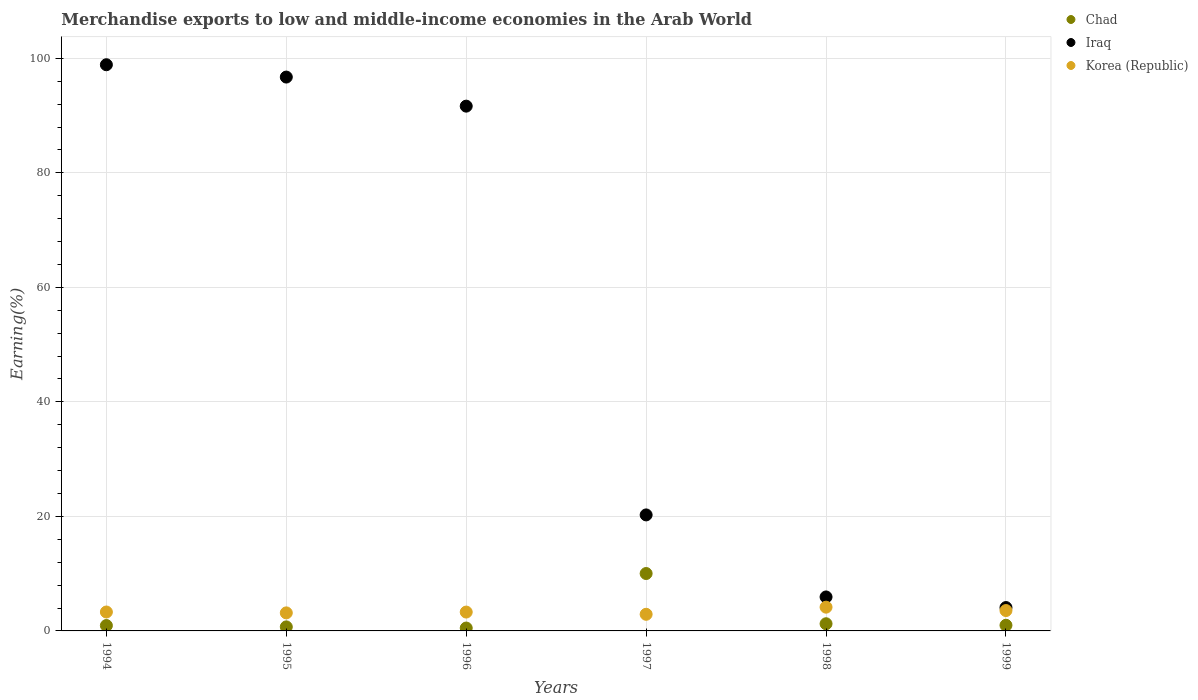What is the percentage of amount earned from merchandise exports in Chad in 1999?
Give a very brief answer. 0.99. Across all years, what is the maximum percentage of amount earned from merchandise exports in Chad?
Provide a succinct answer. 10.02. Across all years, what is the minimum percentage of amount earned from merchandise exports in Korea (Republic)?
Offer a terse response. 2.9. In which year was the percentage of amount earned from merchandise exports in Iraq minimum?
Your response must be concise. 1999. What is the total percentage of amount earned from merchandise exports in Korea (Republic) in the graph?
Offer a very short reply. 20.36. What is the difference between the percentage of amount earned from merchandise exports in Chad in 1995 and that in 1999?
Make the answer very short. -0.28. What is the difference between the percentage of amount earned from merchandise exports in Chad in 1998 and the percentage of amount earned from merchandise exports in Iraq in 1995?
Give a very brief answer. -95.47. What is the average percentage of amount earned from merchandise exports in Korea (Republic) per year?
Your response must be concise. 3.39. In the year 1994, what is the difference between the percentage of amount earned from merchandise exports in Korea (Republic) and percentage of amount earned from merchandise exports in Chad?
Keep it short and to the point. 2.37. What is the ratio of the percentage of amount earned from merchandise exports in Korea (Republic) in 1996 to that in 1997?
Your response must be concise. 1.13. What is the difference between the highest and the second highest percentage of amount earned from merchandise exports in Iraq?
Ensure brevity in your answer.  2.15. What is the difference between the highest and the lowest percentage of amount earned from merchandise exports in Iraq?
Keep it short and to the point. 94.8. Is the sum of the percentage of amount earned from merchandise exports in Iraq in 1995 and 1997 greater than the maximum percentage of amount earned from merchandise exports in Korea (Republic) across all years?
Your answer should be very brief. Yes. Is it the case that in every year, the sum of the percentage of amount earned from merchandise exports in Korea (Republic) and percentage of amount earned from merchandise exports in Iraq  is greater than the percentage of amount earned from merchandise exports in Chad?
Provide a short and direct response. Yes. Does the percentage of amount earned from merchandise exports in Chad monotonically increase over the years?
Offer a very short reply. No. Is the percentage of amount earned from merchandise exports in Chad strictly less than the percentage of amount earned from merchandise exports in Iraq over the years?
Your answer should be compact. Yes. How many dotlines are there?
Your answer should be compact. 3. What is the difference between two consecutive major ticks on the Y-axis?
Ensure brevity in your answer.  20. Does the graph contain grids?
Offer a terse response. Yes. How many legend labels are there?
Offer a very short reply. 3. How are the legend labels stacked?
Give a very brief answer. Vertical. What is the title of the graph?
Provide a short and direct response. Merchandise exports to low and middle-income economies in the Arab World. Does "Iceland" appear as one of the legend labels in the graph?
Give a very brief answer. No. What is the label or title of the X-axis?
Offer a terse response. Years. What is the label or title of the Y-axis?
Provide a succinct answer. Earning(%). What is the Earning(%) of Chad in 1994?
Your answer should be compact. 0.94. What is the Earning(%) of Iraq in 1994?
Offer a terse response. 98.88. What is the Earning(%) of Korea (Republic) in 1994?
Offer a terse response. 3.3. What is the Earning(%) of Chad in 1995?
Give a very brief answer. 0.7. What is the Earning(%) of Iraq in 1995?
Offer a terse response. 96.73. What is the Earning(%) in Korea (Republic) in 1995?
Offer a very short reply. 3.15. What is the Earning(%) of Chad in 1996?
Ensure brevity in your answer.  0.5. What is the Earning(%) in Iraq in 1996?
Provide a short and direct response. 91.65. What is the Earning(%) of Korea (Republic) in 1996?
Your answer should be very brief. 3.29. What is the Earning(%) of Chad in 1997?
Provide a short and direct response. 10.02. What is the Earning(%) of Iraq in 1997?
Ensure brevity in your answer.  20.26. What is the Earning(%) of Korea (Republic) in 1997?
Your response must be concise. 2.9. What is the Earning(%) in Chad in 1998?
Offer a very short reply. 1.25. What is the Earning(%) in Iraq in 1998?
Your answer should be compact. 5.93. What is the Earning(%) of Korea (Republic) in 1998?
Provide a short and direct response. 4.15. What is the Earning(%) of Chad in 1999?
Your response must be concise. 0.99. What is the Earning(%) in Iraq in 1999?
Your answer should be very brief. 4.08. What is the Earning(%) of Korea (Republic) in 1999?
Give a very brief answer. 3.56. Across all years, what is the maximum Earning(%) in Chad?
Make the answer very short. 10.02. Across all years, what is the maximum Earning(%) of Iraq?
Offer a very short reply. 98.88. Across all years, what is the maximum Earning(%) in Korea (Republic)?
Your response must be concise. 4.15. Across all years, what is the minimum Earning(%) in Chad?
Keep it short and to the point. 0.5. Across all years, what is the minimum Earning(%) of Iraq?
Make the answer very short. 4.08. Across all years, what is the minimum Earning(%) in Korea (Republic)?
Keep it short and to the point. 2.9. What is the total Earning(%) of Chad in the graph?
Your response must be concise. 14.41. What is the total Earning(%) in Iraq in the graph?
Ensure brevity in your answer.  317.53. What is the total Earning(%) of Korea (Republic) in the graph?
Give a very brief answer. 20.36. What is the difference between the Earning(%) in Chad in 1994 and that in 1995?
Keep it short and to the point. 0.23. What is the difference between the Earning(%) of Iraq in 1994 and that in 1995?
Your response must be concise. 2.15. What is the difference between the Earning(%) of Korea (Republic) in 1994 and that in 1995?
Keep it short and to the point. 0.15. What is the difference between the Earning(%) in Chad in 1994 and that in 1996?
Keep it short and to the point. 0.43. What is the difference between the Earning(%) in Iraq in 1994 and that in 1996?
Offer a terse response. 7.23. What is the difference between the Earning(%) of Korea (Republic) in 1994 and that in 1996?
Ensure brevity in your answer.  0.01. What is the difference between the Earning(%) in Chad in 1994 and that in 1997?
Keep it short and to the point. -9.09. What is the difference between the Earning(%) in Iraq in 1994 and that in 1997?
Your answer should be very brief. 78.62. What is the difference between the Earning(%) in Korea (Republic) in 1994 and that in 1997?
Your answer should be compact. 0.4. What is the difference between the Earning(%) in Chad in 1994 and that in 1998?
Keep it short and to the point. -0.31. What is the difference between the Earning(%) in Iraq in 1994 and that in 1998?
Provide a succinct answer. 92.95. What is the difference between the Earning(%) in Korea (Republic) in 1994 and that in 1998?
Provide a short and direct response. -0.85. What is the difference between the Earning(%) of Chad in 1994 and that in 1999?
Keep it short and to the point. -0.05. What is the difference between the Earning(%) in Iraq in 1994 and that in 1999?
Offer a very short reply. 94.8. What is the difference between the Earning(%) in Korea (Republic) in 1994 and that in 1999?
Your answer should be very brief. -0.25. What is the difference between the Earning(%) in Chad in 1995 and that in 1996?
Your answer should be very brief. 0.2. What is the difference between the Earning(%) of Iraq in 1995 and that in 1996?
Your answer should be very brief. 5.08. What is the difference between the Earning(%) in Korea (Republic) in 1995 and that in 1996?
Offer a very short reply. -0.14. What is the difference between the Earning(%) of Chad in 1995 and that in 1997?
Provide a short and direct response. -9.32. What is the difference between the Earning(%) in Iraq in 1995 and that in 1997?
Your response must be concise. 76.47. What is the difference between the Earning(%) in Korea (Republic) in 1995 and that in 1997?
Your answer should be compact. 0.25. What is the difference between the Earning(%) in Chad in 1995 and that in 1998?
Your response must be concise. -0.55. What is the difference between the Earning(%) of Iraq in 1995 and that in 1998?
Make the answer very short. 90.79. What is the difference between the Earning(%) in Korea (Republic) in 1995 and that in 1998?
Your answer should be compact. -1. What is the difference between the Earning(%) in Chad in 1995 and that in 1999?
Provide a succinct answer. -0.28. What is the difference between the Earning(%) in Iraq in 1995 and that in 1999?
Provide a succinct answer. 92.65. What is the difference between the Earning(%) in Korea (Republic) in 1995 and that in 1999?
Keep it short and to the point. -0.41. What is the difference between the Earning(%) of Chad in 1996 and that in 1997?
Offer a very short reply. -9.52. What is the difference between the Earning(%) of Iraq in 1996 and that in 1997?
Provide a short and direct response. 71.39. What is the difference between the Earning(%) of Korea (Republic) in 1996 and that in 1997?
Your answer should be very brief. 0.39. What is the difference between the Earning(%) in Chad in 1996 and that in 1998?
Offer a terse response. -0.75. What is the difference between the Earning(%) in Iraq in 1996 and that in 1998?
Give a very brief answer. 85.71. What is the difference between the Earning(%) in Korea (Republic) in 1996 and that in 1998?
Provide a succinct answer. -0.86. What is the difference between the Earning(%) in Chad in 1996 and that in 1999?
Offer a terse response. -0.48. What is the difference between the Earning(%) in Iraq in 1996 and that in 1999?
Keep it short and to the point. 87.57. What is the difference between the Earning(%) of Korea (Republic) in 1996 and that in 1999?
Keep it short and to the point. -0.26. What is the difference between the Earning(%) in Chad in 1997 and that in 1998?
Your answer should be very brief. 8.77. What is the difference between the Earning(%) in Iraq in 1997 and that in 1998?
Provide a short and direct response. 14.33. What is the difference between the Earning(%) in Korea (Republic) in 1997 and that in 1998?
Keep it short and to the point. -1.25. What is the difference between the Earning(%) of Chad in 1997 and that in 1999?
Your answer should be very brief. 9.04. What is the difference between the Earning(%) of Iraq in 1997 and that in 1999?
Give a very brief answer. 16.18. What is the difference between the Earning(%) of Korea (Republic) in 1997 and that in 1999?
Your answer should be very brief. -0.65. What is the difference between the Earning(%) in Chad in 1998 and that in 1999?
Your answer should be compact. 0.27. What is the difference between the Earning(%) in Iraq in 1998 and that in 1999?
Your answer should be compact. 1.85. What is the difference between the Earning(%) of Korea (Republic) in 1998 and that in 1999?
Keep it short and to the point. 0.59. What is the difference between the Earning(%) of Chad in 1994 and the Earning(%) of Iraq in 1995?
Offer a very short reply. -95.79. What is the difference between the Earning(%) of Chad in 1994 and the Earning(%) of Korea (Republic) in 1995?
Provide a succinct answer. -2.21. What is the difference between the Earning(%) of Iraq in 1994 and the Earning(%) of Korea (Republic) in 1995?
Provide a short and direct response. 95.73. What is the difference between the Earning(%) of Chad in 1994 and the Earning(%) of Iraq in 1996?
Provide a succinct answer. -90.71. What is the difference between the Earning(%) in Chad in 1994 and the Earning(%) in Korea (Republic) in 1996?
Your answer should be compact. -2.35. What is the difference between the Earning(%) in Iraq in 1994 and the Earning(%) in Korea (Republic) in 1996?
Your response must be concise. 95.59. What is the difference between the Earning(%) in Chad in 1994 and the Earning(%) in Iraq in 1997?
Offer a very short reply. -19.32. What is the difference between the Earning(%) of Chad in 1994 and the Earning(%) of Korea (Republic) in 1997?
Offer a very short reply. -1.96. What is the difference between the Earning(%) in Iraq in 1994 and the Earning(%) in Korea (Republic) in 1997?
Provide a succinct answer. 95.98. What is the difference between the Earning(%) of Chad in 1994 and the Earning(%) of Iraq in 1998?
Offer a terse response. -4.99. What is the difference between the Earning(%) of Chad in 1994 and the Earning(%) of Korea (Republic) in 1998?
Your answer should be very brief. -3.21. What is the difference between the Earning(%) in Iraq in 1994 and the Earning(%) in Korea (Republic) in 1998?
Provide a succinct answer. 94.73. What is the difference between the Earning(%) of Chad in 1994 and the Earning(%) of Iraq in 1999?
Provide a short and direct response. -3.14. What is the difference between the Earning(%) in Chad in 1994 and the Earning(%) in Korea (Republic) in 1999?
Keep it short and to the point. -2.62. What is the difference between the Earning(%) in Iraq in 1994 and the Earning(%) in Korea (Republic) in 1999?
Your answer should be very brief. 95.32. What is the difference between the Earning(%) of Chad in 1995 and the Earning(%) of Iraq in 1996?
Provide a succinct answer. -90.94. What is the difference between the Earning(%) in Chad in 1995 and the Earning(%) in Korea (Republic) in 1996?
Keep it short and to the point. -2.59. What is the difference between the Earning(%) of Iraq in 1995 and the Earning(%) of Korea (Republic) in 1996?
Offer a very short reply. 93.43. What is the difference between the Earning(%) of Chad in 1995 and the Earning(%) of Iraq in 1997?
Ensure brevity in your answer.  -19.56. What is the difference between the Earning(%) of Chad in 1995 and the Earning(%) of Korea (Republic) in 1997?
Offer a very short reply. -2.2. What is the difference between the Earning(%) of Iraq in 1995 and the Earning(%) of Korea (Republic) in 1997?
Give a very brief answer. 93.82. What is the difference between the Earning(%) of Chad in 1995 and the Earning(%) of Iraq in 1998?
Give a very brief answer. -5.23. What is the difference between the Earning(%) of Chad in 1995 and the Earning(%) of Korea (Republic) in 1998?
Provide a short and direct response. -3.44. What is the difference between the Earning(%) in Iraq in 1995 and the Earning(%) in Korea (Republic) in 1998?
Ensure brevity in your answer.  92.58. What is the difference between the Earning(%) of Chad in 1995 and the Earning(%) of Iraq in 1999?
Make the answer very short. -3.38. What is the difference between the Earning(%) of Chad in 1995 and the Earning(%) of Korea (Republic) in 1999?
Offer a terse response. -2.85. What is the difference between the Earning(%) in Iraq in 1995 and the Earning(%) in Korea (Republic) in 1999?
Ensure brevity in your answer.  93.17. What is the difference between the Earning(%) in Chad in 1996 and the Earning(%) in Iraq in 1997?
Offer a very short reply. -19.76. What is the difference between the Earning(%) in Chad in 1996 and the Earning(%) in Korea (Republic) in 1997?
Offer a very short reply. -2.4. What is the difference between the Earning(%) of Iraq in 1996 and the Earning(%) of Korea (Republic) in 1997?
Your response must be concise. 88.74. What is the difference between the Earning(%) of Chad in 1996 and the Earning(%) of Iraq in 1998?
Provide a short and direct response. -5.43. What is the difference between the Earning(%) in Chad in 1996 and the Earning(%) in Korea (Republic) in 1998?
Your response must be concise. -3.65. What is the difference between the Earning(%) of Iraq in 1996 and the Earning(%) of Korea (Republic) in 1998?
Your answer should be very brief. 87.5. What is the difference between the Earning(%) of Chad in 1996 and the Earning(%) of Iraq in 1999?
Your answer should be very brief. -3.58. What is the difference between the Earning(%) of Chad in 1996 and the Earning(%) of Korea (Republic) in 1999?
Your answer should be very brief. -3.05. What is the difference between the Earning(%) in Iraq in 1996 and the Earning(%) in Korea (Republic) in 1999?
Keep it short and to the point. 88.09. What is the difference between the Earning(%) of Chad in 1997 and the Earning(%) of Iraq in 1998?
Offer a terse response. 4.09. What is the difference between the Earning(%) of Chad in 1997 and the Earning(%) of Korea (Republic) in 1998?
Your answer should be very brief. 5.87. What is the difference between the Earning(%) in Iraq in 1997 and the Earning(%) in Korea (Republic) in 1998?
Your answer should be very brief. 16.11. What is the difference between the Earning(%) in Chad in 1997 and the Earning(%) in Iraq in 1999?
Provide a short and direct response. 5.94. What is the difference between the Earning(%) in Chad in 1997 and the Earning(%) in Korea (Republic) in 1999?
Your response must be concise. 6.47. What is the difference between the Earning(%) in Iraq in 1997 and the Earning(%) in Korea (Republic) in 1999?
Offer a terse response. 16.7. What is the difference between the Earning(%) of Chad in 1998 and the Earning(%) of Iraq in 1999?
Keep it short and to the point. -2.83. What is the difference between the Earning(%) in Chad in 1998 and the Earning(%) in Korea (Republic) in 1999?
Keep it short and to the point. -2.31. What is the difference between the Earning(%) of Iraq in 1998 and the Earning(%) of Korea (Republic) in 1999?
Offer a terse response. 2.38. What is the average Earning(%) in Chad per year?
Offer a very short reply. 2.4. What is the average Earning(%) in Iraq per year?
Provide a short and direct response. 52.92. What is the average Earning(%) in Korea (Republic) per year?
Make the answer very short. 3.39. In the year 1994, what is the difference between the Earning(%) of Chad and Earning(%) of Iraq?
Provide a succinct answer. -97.94. In the year 1994, what is the difference between the Earning(%) of Chad and Earning(%) of Korea (Republic)?
Make the answer very short. -2.37. In the year 1994, what is the difference between the Earning(%) of Iraq and Earning(%) of Korea (Republic)?
Provide a succinct answer. 95.57. In the year 1995, what is the difference between the Earning(%) in Chad and Earning(%) in Iraq?
Ensure brevity in your answer.  -96.02. In the year 1995, what is the difference between the Earning(%) in Chad and Earning(%) in Korea (Republic)?
Make the answer very short. -2.45. In the year 1995, what is the difference between the Earning(%) in Iraq and Earning(%) in Korea (Republic)?
Keep it short and to the point. 93.57. In the year 1996, what is the difference between the Earning(%) of Chad and Earning(%) of Iraq?
Your response must be concise. -91.14. In the year 1996, what is the difference between the Earning(%) of Chad and Earning(%) of Korea (Republic)?
Provide a succinct answer. -2.79. In the year 1996, what is the difference between the Earning(%) of Iraq and Earning(%) of Korea (Republic)?
Ensure brevity in your answer.  88.35. In the year 1997, what is the difference between the Earning(%) in Chad and Earning(%) in Iraq?
Give a very brief answer. -10.24. In the year 1997, what is the difference between the Earning(%) in Chad and Earning(%) in Korea (Republic)?
Make the answer very short. 7.12. In the year 1997, what is the difference between the Earning(%) of Iraq and Earning(%) of Korea (Republic)?
Provide a short and direct response. 17.36. In the year 1998, what is the difference between the Earning(%) in Chad and Earning(%) in Iraq?
Ensure brevity in your answer.  -4.68. In the year 1998, what is the difference between the Earning(%) of Chad and Earning(%) of Korea (Republic)?
Keep it short and to the point. -2.9. In the year 1998, what is the difference between the Earning(%) of Iraq and Earning(%) of Korea (Republic)?
Your answer should be compact. 1.78. In the year 1999, what is the difference between the Earning(%) of Chad and Earning(%) of Iraq?
Provide a succinct answer. -3.09. In the year 1999, what is the difference between the Earning(%) of Chad and Earning(%) of Korea (Republic)?
Give a very brief answer. -2.57. In the year 1999, what is the difference between the Earning(%) in Iraq and Earning(%) in Korea (Republic)?
Your answer should be compact. 0.52. What is the ratio of the Earning(%) of Chad in 1994 to that in 1995?
Offer a very short reply. 1.33. What is the ratio of the Earning(%) of Iraq in 1994 to that in 1995?
Offer a terse response. 1.02. What is the ratio of the Earning(%) in Korea (Republic) in 1994 to that in 1995?
Make the answer very short. 1.05. What is the ratio of the Earning(%) of Chad in 1994 to that in 1996?
Your answer should be compact. 1.86. What is the ratio of the Earning(%) in Iraq in 1994 to that in 1996?
Your response must be concise. 1.08. What is the ratio of the Earning(%) of Chad in 1994 to that in 1997?
Offer a very short reply. 0.09. What is the ratio of the Earning(%) in Iraq in 1994 to that in 1997?
Provide a succinct answer. 4.88. What is the ratio of the Earning(%) of Korea (Republic) in 1994 to that in 1997?
Provide a succinct answer. 1.14. What is the ratio of the Earning(%) of Chad in 1994 to that in 1998?
Your answer should be compact. 0.75. What is the ratio of the Earning(%) in Iraq in 1994 to that in 1998?
Your response must be concise. 16.66. What is the ratio of the Earning(%) of Korea (Republic) in 1994 to that in 1998?
Your answer should be compact. 0.8. What is the ratio of the Earning(%) in Iraq in 1994 to that in 1999?
Give a very brief answer. 24.24. What is the ratio of the Earning(%) in Korea (Republic) in 1994 to that in 1999?
Provide a short and direct response. 0.93. What is the ratio of the Earning(%) in Chad in 1995 to that in 1996?
Provide a succinct answer. 1.4. What is the ratio of the Earning(%) in Iraq in 1995 to that in 1996?
Give a very brief answer. 1.06. What is the ratio of the Earning(%) of Korea (Republic) in 1995 to that in 1996?
Your answer should be very brief. 0.96. What is the ratio of the Earning(%) in Chad in 1995 to that in 1997?
Make the answer very short. 0.07. What is the ratio of the Earning(%) of Iraq in 1995 to that in 1997?
Offer a terse response. 4.77. What is the ratio of the Earning(%) of Korea (Republic) in 1995 to that in 1997?
Keep it short and to the point. 1.09. What is the ratio of the Earning(%) in Chad in 1995 to that in 1998?
Give a very brief answer. 0.56. What is the ratio of the Earning(%) in Iraq in 1995 to that in 1998?
Offer a terse response. 16.3. What is the ratio of the Earning(%) in Korea (Republic) in 1995 to that in 1998?
Your answer should be very brief. 0.76. What is the ratio of the Earning(%) in Chad in 1995 to that in 1999?
Your response must be concise. 0.71. What is the ratio of the Earning(%) of Iraq in 1995 to that in 1999?
Your answer should be compact. 23.71. What is the ratio of the Earning(%) of Korea (Republic) in 1995 to that in 1999?
Offer a very short reply. 0.89. What is the ratio of the Earning(%) in Chad in 1996 to that in 1997?
Your answer should be compact. 0.05. What is the ratio of the Earning(%) of Iraq in 1996 to that in 1997?
Offer a very short reply. 4.52. What is the ratio of the Earning(%) of Korea (Republic) in 1996 to that in 1997?
Your answer should be very brief. 1.13. What is the ratio of the Earning(%) in Chad in 1996 to that in 1998?
Offer a terse response. 0.4. What is the ratio of the Earning(%) of Iraq in 1996 to that in 1998?
Give a very brief answer. 15.45. What is the ratio of the Earning(%) in Korea (Republic) in 1996 to that in 1998?
Provide a succinct answer. 0.79. What is the ratio of the Earning(%) in Chad in 1996 to that in 1999?
Offer a very short reply. 0.51. What is the ratio of the Earning(%) in Iraq in 1996 to that in 1999?
Your response must be concise. 22.46. What is the ratio of the Earning(%) of Korea (Republic) in 1996 to that in 1999?
Ensure brevity in your answer.  0.93. What is the ratio of the Earning(%) of Chad in 1997 to that in 1998?
Keep it short and to the point. 8.01. What is the ratio of the Earning(%) in Iraq in 1997 to that in 1998?
Provide a short and direct response. 3.41. What is the ratio of the Earning(%) of Korea (Republic) in 1997 to that in 1998?
Offer a very short reply. 0.7. What is the ratio of the Earning(%) in Chad in 1997 to that in 1999?
Make the answer very short. 10.16. What is the ratio of the Earning(%) in Iraq in 1997 to that in 1999?
Provide a succinct answer. 4.97. What is the ratio of the Earning(%) of Korea (Republic) in 1997 to that in 1999?
Your answer should be compact. 0.82. What is the ratio of the Earning(%) in Chad in 1998 to that in 1999?
Your answer should be very brief. 1.27. What is the ratio of the Earning(%) in Iraq in 1998 to that in 1999?
Give a very brief answer. 1.45. What is the ratio of the Earning(%) in Korea (Republic) in 1998 to that in 1999?
Offer a very short reply. 1.17. What is the difference between the highest and the second highest Earning(%) of Chad?
Offer a very short reply. 8.77. What is the difference between the highest and the second highest Earning(%) in Iraq?
Provide a short and direct response. 2.15. What is the difference between the highest and the second highest Earning(%) in Korea (Republic)?
Provide a succinct answer. 0.59. What is the difference between the highest and the lowest Earning(%) in Chad?
Make the answer very short. 9.52. What is the difference between the highest and the lowest Earning(%) of Iraq?
Ensure brevity in your answer.  94.8. What is the difference between the highest and the lowest Earning(%) in Korea (Republic)?
Your response must be concise. 1.25. 